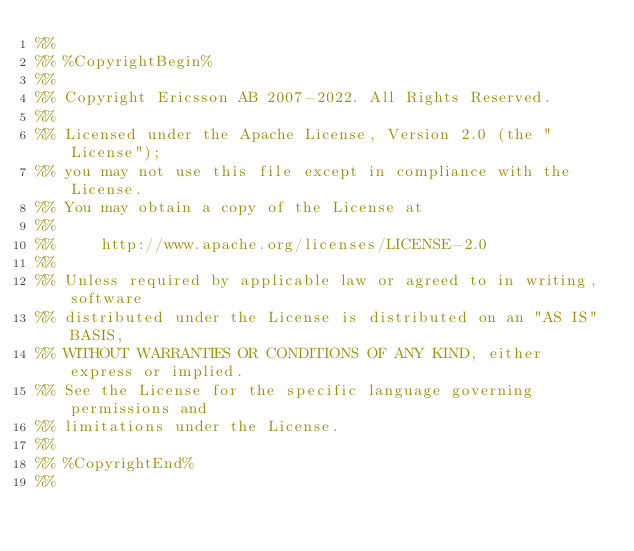Convert code to text. <code><loc_0><loc_0><loc_500><loc_500><_Erlang_>%%
%% %CopyrightBegin%
%%
%% Copyright Ericsson AB 2007-2022. All Rights Reserved.
%%
%% Licensed under the Apache License, Version 2.0 (the "License");
%% you may not use this file except in compliance with the License.
%% You may obtain a copy of the License at
%%
%%     http://www.apache.org/licenses/LICENSE-2.0
%%
%% Unless required by applicable law or agreed to in writing, software
%% distributed under the License is distributed on an "AS IS" BASIS,
%% WITHOUT WARRANTIES OR CONDITIONS OF ANY KIND, either express or implied.
%% See the License for the specific language governing permissions and
%% limitations under the License.
%%
%% %CopyrightEnd%
%%</code> 